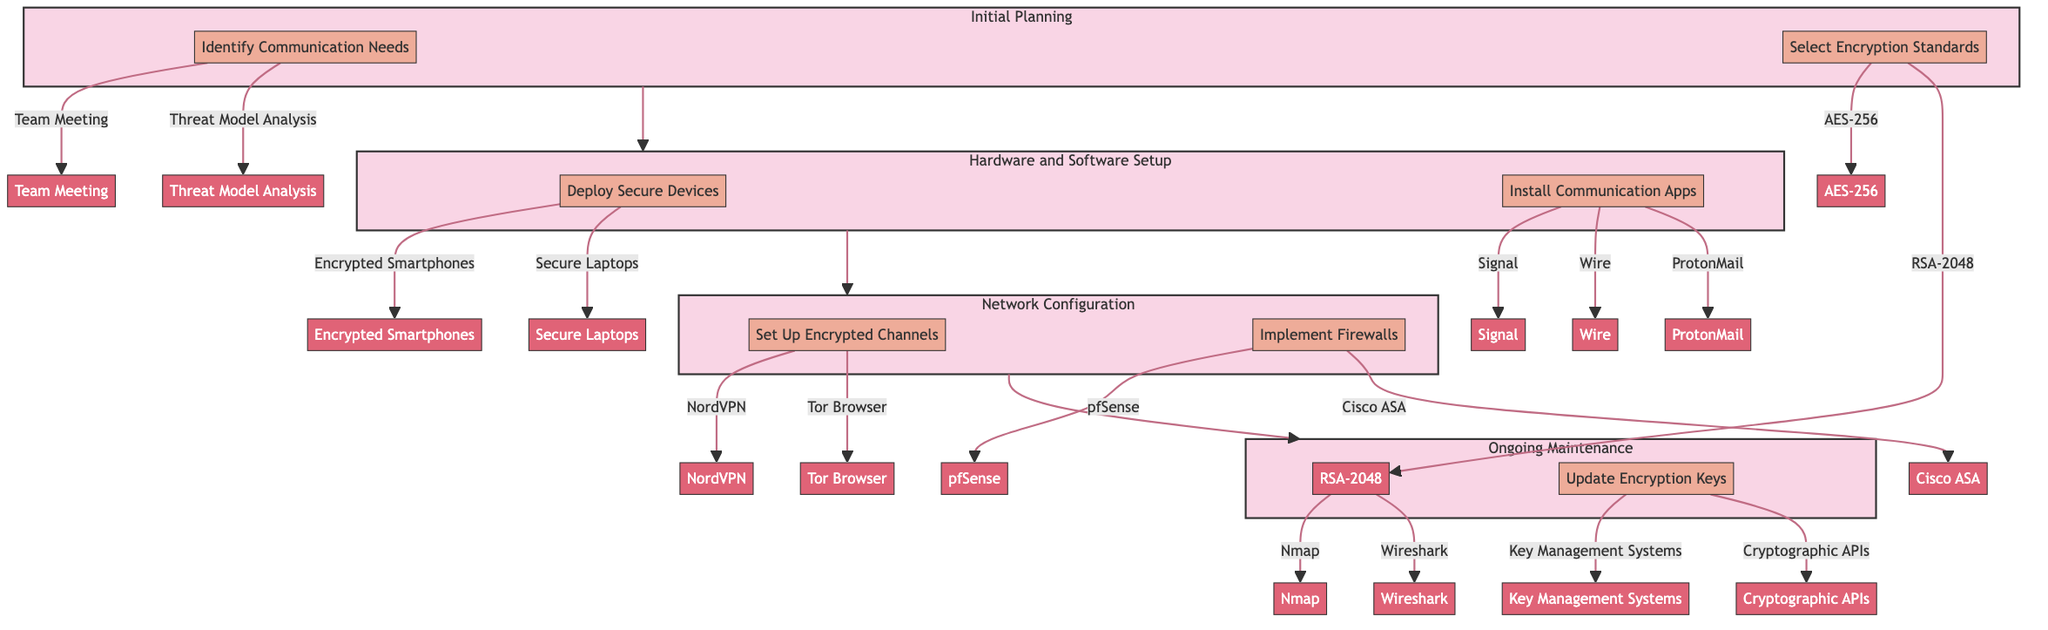what is the title of the diagram? The title of the diagram is directly mentioned at the top and states the focus of the clinical pathway.
Answer: Secure Communication Channel Establishment for Heist Operations how many stages are in the pathway? The diagram shows a sequence of connected stages, which can be counted. There are four distinct stages within the diagram.
Answer: 4 what is the first step in the Initial Planning stage? The first step within the Initial Planning stage is listed in the diagram and describes the initial action to be taken.
Answer: Identify Communication Needs which tool is used for "Select Encryption Standards"? The tool associated with the step "Select Encryption Standards" is indicated in the diagram. The specific tool mentioned is directly associated with this step.
Answer: AES-256 what is the last step in the Ongoing Maintenance stage? The last step in the Ongoing Maintenance stage can be identified by examining the listed steps in this stage. It is the last action outlined in that stage.
Answer: Update Encryption Keys how many tools are listed under Network Configuration? The tools located under the Network Configuration stage can be counted from the diagram. Two tools are specified in this section.
Answer: 2 which step follows "Deploy Secure Devices"? By following the arrows in the diagram, we can see the sequence of steps and determine the next action after "Deploy Secure Devices."
Answer: Install Communication Apps what is the primary purpose of "Regular Security Audits"? The purpose of "Regular Security Audits" can be inferred from its labeled description in the diagram. It serves to review the systems periodically.
Answer: Perform periodic reviews of the communication systems which stage comes before Hardware and Software Setup? The flow of the diagram shows a clear progression from one stage to the next. By tracing back from Hardware and Software Setup, we identify its predecessor.
Answer: Initial Planning 